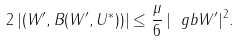Convert formula to latex. <formula><loc_0><loc_0><loc_500><loc_500>2 \, | ( W ^ { \prime } , B ( W ^ { \prime } , U ^ { * } ) ) | \leq \frac { \mu } { 6 } \, | \ g b W ^ { \prime } | ^ { 2 } .</formula> 